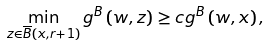<formula> <loc_0><loc_0><loc_500><loc_500>\min _ { z \in \overline { B } \left ( x , r + 1 \right ) } g ^ { B } \left ( w , z \right ) \geq c g ^ { B } \left ( w , x \right ) ,</formula> 